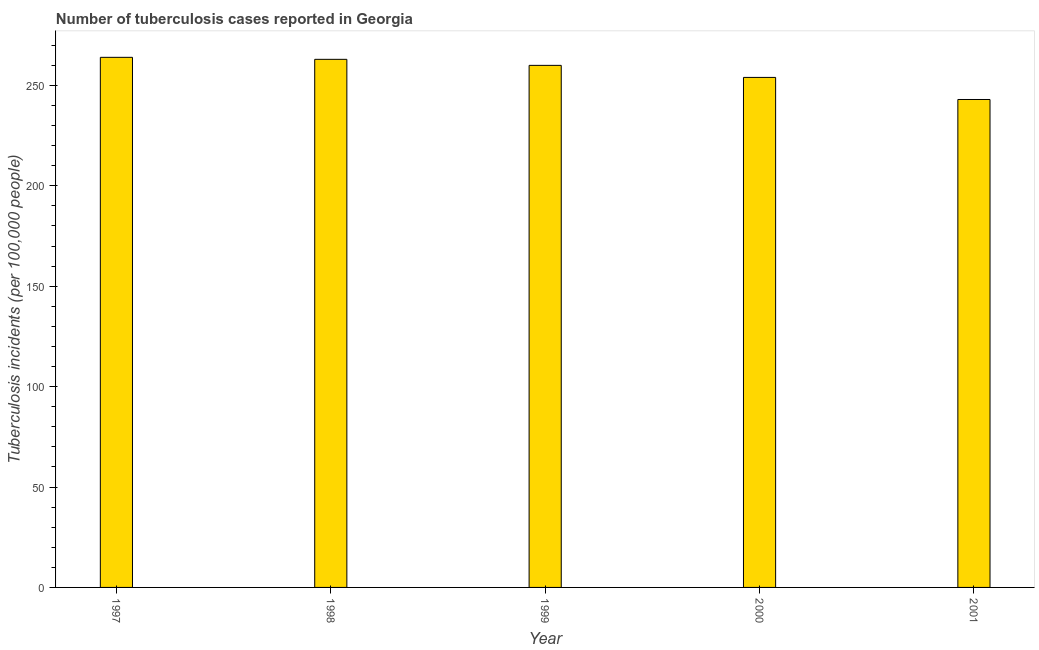Does the graph contain any zero values?
Ensure brevity in your answer.  No. What is the title of the graph?
Offer a very short reply. Number of tuberculosis cases reported in Georgia. What is the label or title of the X-axis?
Provide a succinct answer. Year. What is the label or title of the Y-axis?
Keep it short and to the point. Tuberculosis incidents (per 100,0 people). What is the number of tuberculosis incidents in 1998?
Keep it short and to the point. 263. Across all years, what is the maximum number of tuberculosis incidents?
Offer a terse response. 264. Across all years, what is the minimum number of tuberculosis incidents?
Your response must be concise. 243. In which year was the number of tuberculosis incidents maximum?
Offer a very short reply. 1997. In which year was the number of tuberculosis incidents minimum?
Offer a terse response. 2001. What is the sum of the number of tuberculosis incidents?
Keep it short and to the point. 1284. What is the difference between the number of tuberculosis incidents in 1997 and 1999?
Ensure brevity in your answer.  4. What is the average number of tuberculosis incidents per year?
Your answer should be compact. 256. What is the median number of tuberculosis incidents?
Provide a succinct answer. 260. In how many years, is the number of tuberculosis incidents greater than 20 ?
Make the answer very short. 5. What is the ratio of the number of tuberculosis incidents in 1998 to that in 1999?
Your answer should be very brief. 1.01. Is the number of tuberculosis incidents in 1998 less than that in 1999?
Your answer should be very brief. No. Is the difference between the number of tuberculosis incidents in 2000 and 2001 greater than the difference between any two years?
Keep it short and to the point. No. What is the difference between the highest and the lowest number of tuberculosis incidents?
Keep it short and to the point. 21. What is the difference between two consecutive major ticks on the Y-axis?
Offer a very short reply. 50. What is the Tuberculosis incidents (per 100,000 people) in 1997?
Give a very brief answer. 264. What is the Tuberculosis incidents (per 100,000 people) in 1998?
Offer a terse response. 263. What is the Tuberculosis incidents (per 100,000 people) in 1999?
Offer a terse response. 260. What is the Tuberculosis incidents (per 100,000 people) of 2000?
Provide a short and direct response. 254. What is the Tuberculosis incidents (per 100,000 people) in 2001?
Make the answer very short. 243. What is the difference between the Tuberculosis incidents (per 100,000 people) in 1997 and 1998?
Make the answer very short. 1. What is the difference between the Tuberculosis incidents (per 100,000 people) in 1997 and 1999?
Provide a succinct answer. 4. What is the difference between the Tuberculosis incidents (per 100,000 people) in 1997 and 2000?
Make the answer very short. 10. What is the difference between the Tuberculosis incidents (per 100,000 people) in 1997 and 2001?
Your answer should be compact. 21. What is the difference between the Tuberculosis incidents (per 100,000 people) in 1998 and 2001?
Your answer should be very brief. 20. What is the difference between the Tuberculosis incidents (per 100,000 people) in 1999 and 2001?
Make the answer very short. 17. What is the difference between the Tuberculosis incidents (per 100,000 people) in 2000 and 2001?
Your answer should be compact. 11. What is the ratio of the Tuberculosis incidents (per 100,000 people) in 1997 to that in 1998?
Your answer should be very brief. 1. What is the ratio of the Tuberculosis incidents (per 100,000 people) in 1997 to that in 1999?
Provide a succinct answer. 1.01. What is the ratio of the Tuberculosis incidents (per 100,000 people) in 1997 to that in 2000?
Keep it short and to the point. 1.04. What is the ratio of the Tuberculosis incidents (per 100,000 people) in 1997 to that in 2001?
Provide a succinct answer. 1.09. What is the ratio of the Tuberculosis incidents (per 100,000 people) in 1998 to that in 2000?
Your answer should be very brief. 1.03. What is the ratio of the Tuberculosis incidents (per 100,000 people) in 1998 to that in 2001?
Ensure brevity in your answer.  1.08. What is the ratio of the Tuberculosis incidents (per 100,000 people) in 1999 to that in 2000?
Provide a succinct answer. 1.02. What is the ratio of the Tuberculosis incidents (per 100,000 people) in 1999 to that in 2001?
Provide a succinct answer. 1.07. What is the ratio of the Tuberculosis incidents (per 100,000 people) in 2000 to that in 2001?
Make the answer very short. 1.04. 